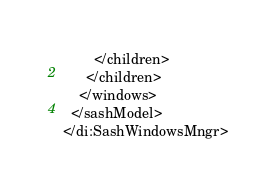Convert code to text. <code><loc_0><loc_0><loc_500><loc_500><_D_>        </children>
      </children>
    </windows>
  </sashModel>
</di:SashWindowsMngr>
</code> 